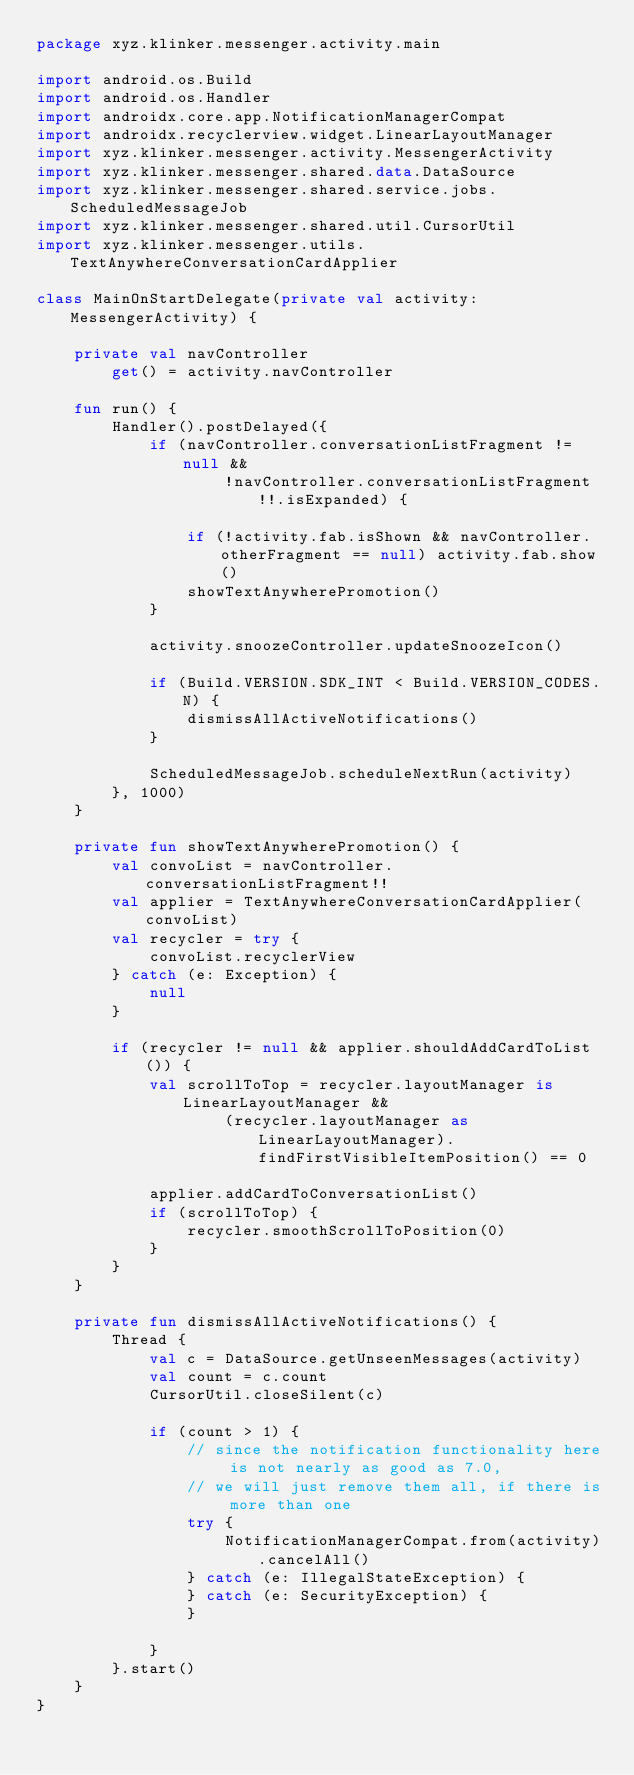<code> <loc_0><loc_0><loc_500><loc_500><_Kotlin_>package xyz.klinker.messenger.activity.main

import android.os.Build
import android.os.Handler
import androidx.core.app.NotificationManagerCompat
import androidx.recyclerview.widget.LinearLayoutManager
import xyz.klinker.messenger.activity.MessengerActivity
import xyz.klinker.messenger.shared.data.DataSource
import xyz.klinker.messenger.shared.service.jobs.ScheduledMessageJob
import xyz.klinker.messenger.shared.util.CursorUtil
import xyz.klinker.messenger.utils.TextAnywhereConversationCardApplier

class MainOnStartDelegate(private val activity: MessengerActivity) {

    private val navController
        get() = activity.navController

    fun run() {
        Handler().postDelayed({
            if (navController.conversationListFragment != null &&
                    !navController.conversationListFragment!!.isExpanded) {

                if (!activity.fab.isShown && navController.otherFragment == null) activity.fab.show()
                showTextAnywherePromotion()
            }

            activity.snoozeController.updateSnoozeIcon()

            if (Build.VERSION.SDK_INT < Build.VERSION_CODES.N) {
                dismissAllActiveNotifications()
            }

            ScheduledMessageJob.scheduleNextRun(activity)
        }, 1000)
    }

    private fun showTextAnywherePromotion() {
        val convoList = navController.conversationListFragment!!
        val applier = TextAnywhereConversationCardApplier(convoList)
        val recycler = try {
            convoList.recyclerView
        } catch (e: Exception) {
            null
        }

        if (recycler != null && applier.shouldAddCardToList()) {
            val scrollToTop = recycler.layoutManager is LinearLayoutManager &&
                    (recycler.layoutManager as LinearLayoutManager).findFirstVisibleItemPosition() == 0

            applier.addCardToConversationList()
            if (scrollToTop) {
                recycler.smoothScrollToPosition(0)
            }
        }
    }

    private fun dismissAllActiveNotifications() {
        Thread {
            val c = DataSource.getUnseenMessages(activity)
            val count = c.count
            CursorUtil.closeSilent(c)

            if (count > 1) {
                // since the notification functionality here is not nearly as good as 7.0,
                // we will just remove them all, if there is more than one
                try {
                    NotificationManagerCompat.from(activity).cancelAll()
                } catch (e: IllegalStateException) {
                } catch (e: SecurityException) {
                }

            }
        }.start()
    }
}</code> 